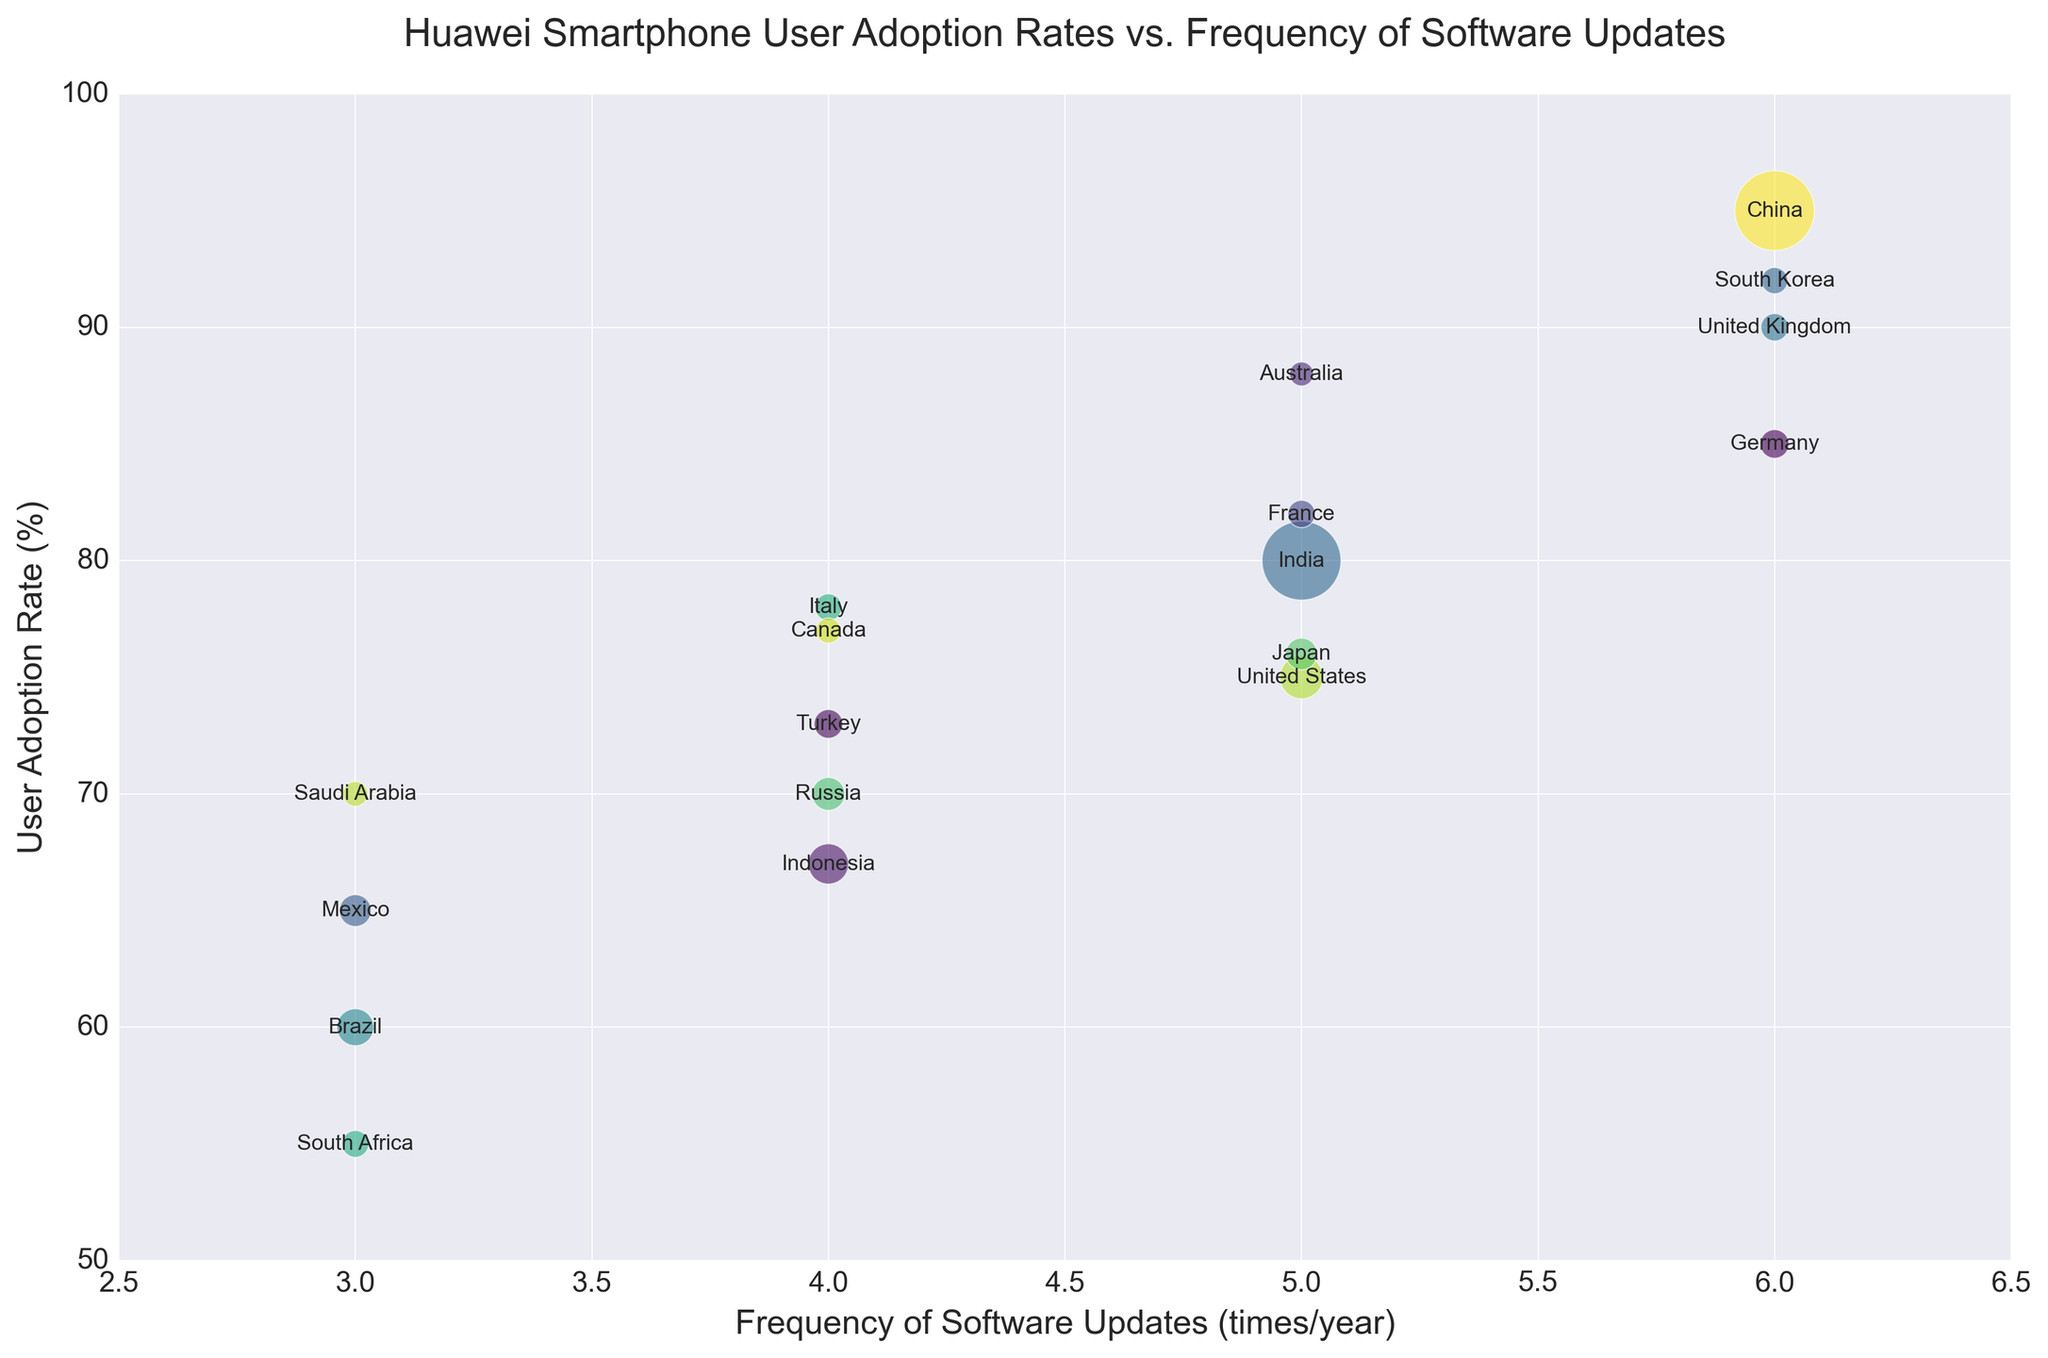Which country has the highest user adoption rate? The country with the largest bubble along the y-axis represents the highest user adoption rate. The country labeled in this bubble is China.
Answer: China Which countries have a frequency of updates of 6 times per year? Look for bubbles positioned at the x-coordinate corresponding to 6. The countries labeled in these bubbles are China, Germany, United Kingdom, and South Korea.
Answer: China, Germany, United Kingdom, South Korea What is the user adoption rate difference between Brazil and Mexico? Locate Brazil and Mexico on the chart. Brazil has a user adoption rate of 60%, and Mexico has 65%. The difference is calculated as 65 - 60 = 5%.
Answer: 5% Which country has the largest bubble? The country with the largest bubble represents the largest population size. The largest bubble on the plot is labelled China.
Answer: China What are the populations of the countries that receive updates 5 times per year? Identify countries at the x-coordinate 5 and read their population sizes from the data: India (1366M), United States (331M), France (65M), Australia (25M), and Japan (126M).
Answer: India (1366M), United States (331M), France (65M), Australia (25M), Japan (126M) Which country has a higher user adoption rate, Italy or France? Locate Italy and France on the y-axis. Italy has a user adoption rate of 78%, and France has 82%. Thus, France has a higher user adoption rate.
Answer: France How does the user adoption rate in South Africa compare to Saudi Arabia? South Africa has an adoption rate of 55%, and Saudi Arabia has 70%. Saudi Arabia's adoption rate is higher.
Answer: Saudi Arabia What is the average user adoption rate for countries with a frequency of updates of 4 times per year? The countries with 4 updates/year are Russia, Italy, Canada, Indonesia, and Turkey. Their adoption rates are 70%, 78%, 77%, 67%, and 73%. The average is calculated as (70 + 78 + 77 + 67 + 73) / 5 = 73%.
Answer: 73% Which country has the smallest bubble? The country with the smallest bubble represents the smallest population size. The smallest bubble on the plot is labeled Saudi Arabia.
Answer: Saudi Arabia How does the update frequency in Germany compare to the United States? Locate Germany and the United States on the plot. Germany has a frequency of updates of 6 times/year, while the United States has 5 times/year. Germany has a higher frequency of updates.
Answer: Germany 